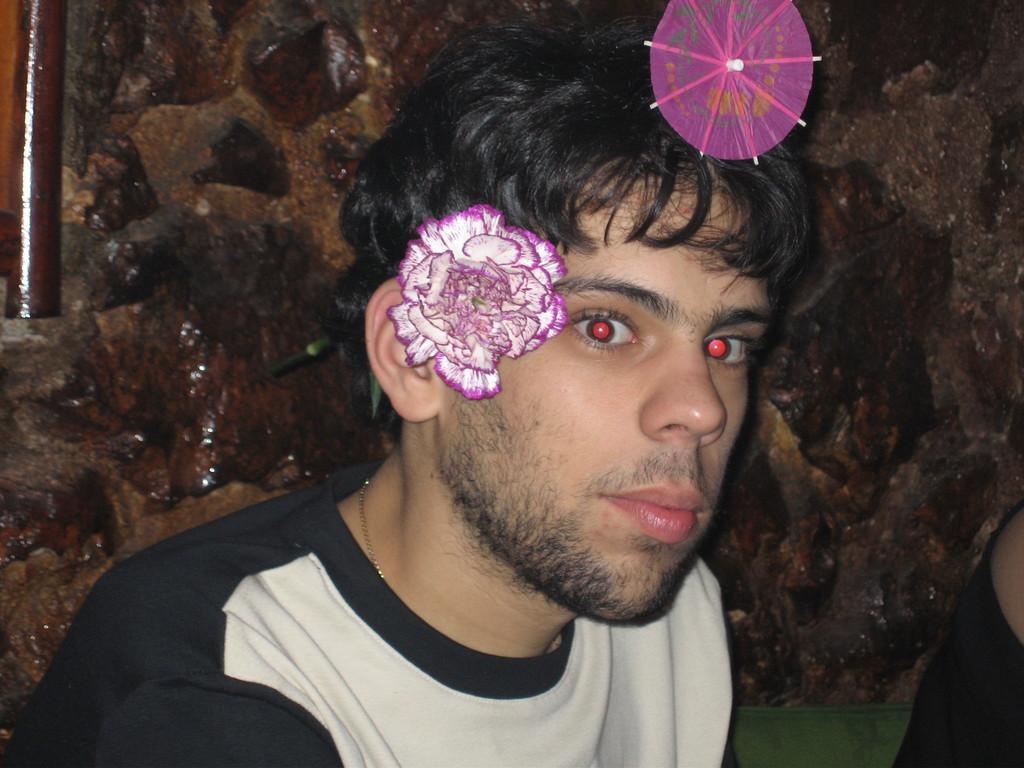In one or two sentences, can you explain what this image depicts? In this picture I can see a man in front who is wearing white and black color t-shirt and I can see a flower on his ear and I can see a pink color thing on his hair. In the background I can see the wall. 